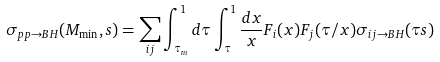<formula> <loc_0><loc_0><loc_500><loc_500>\sigma _ { p p \rightarrow B H } ( M _ { \min } , s ) = \sum _ { i j } \int ^ { 1 } _ { \tau _ { m } } d \tau \int ^ { 1 } _ { \tau } \frac { d x } { x } F _ { i } ( x ) F _ { j } ( \tau / x ) \sigma _ { i j \rightarrow B H } ( \tau s )</formula> 